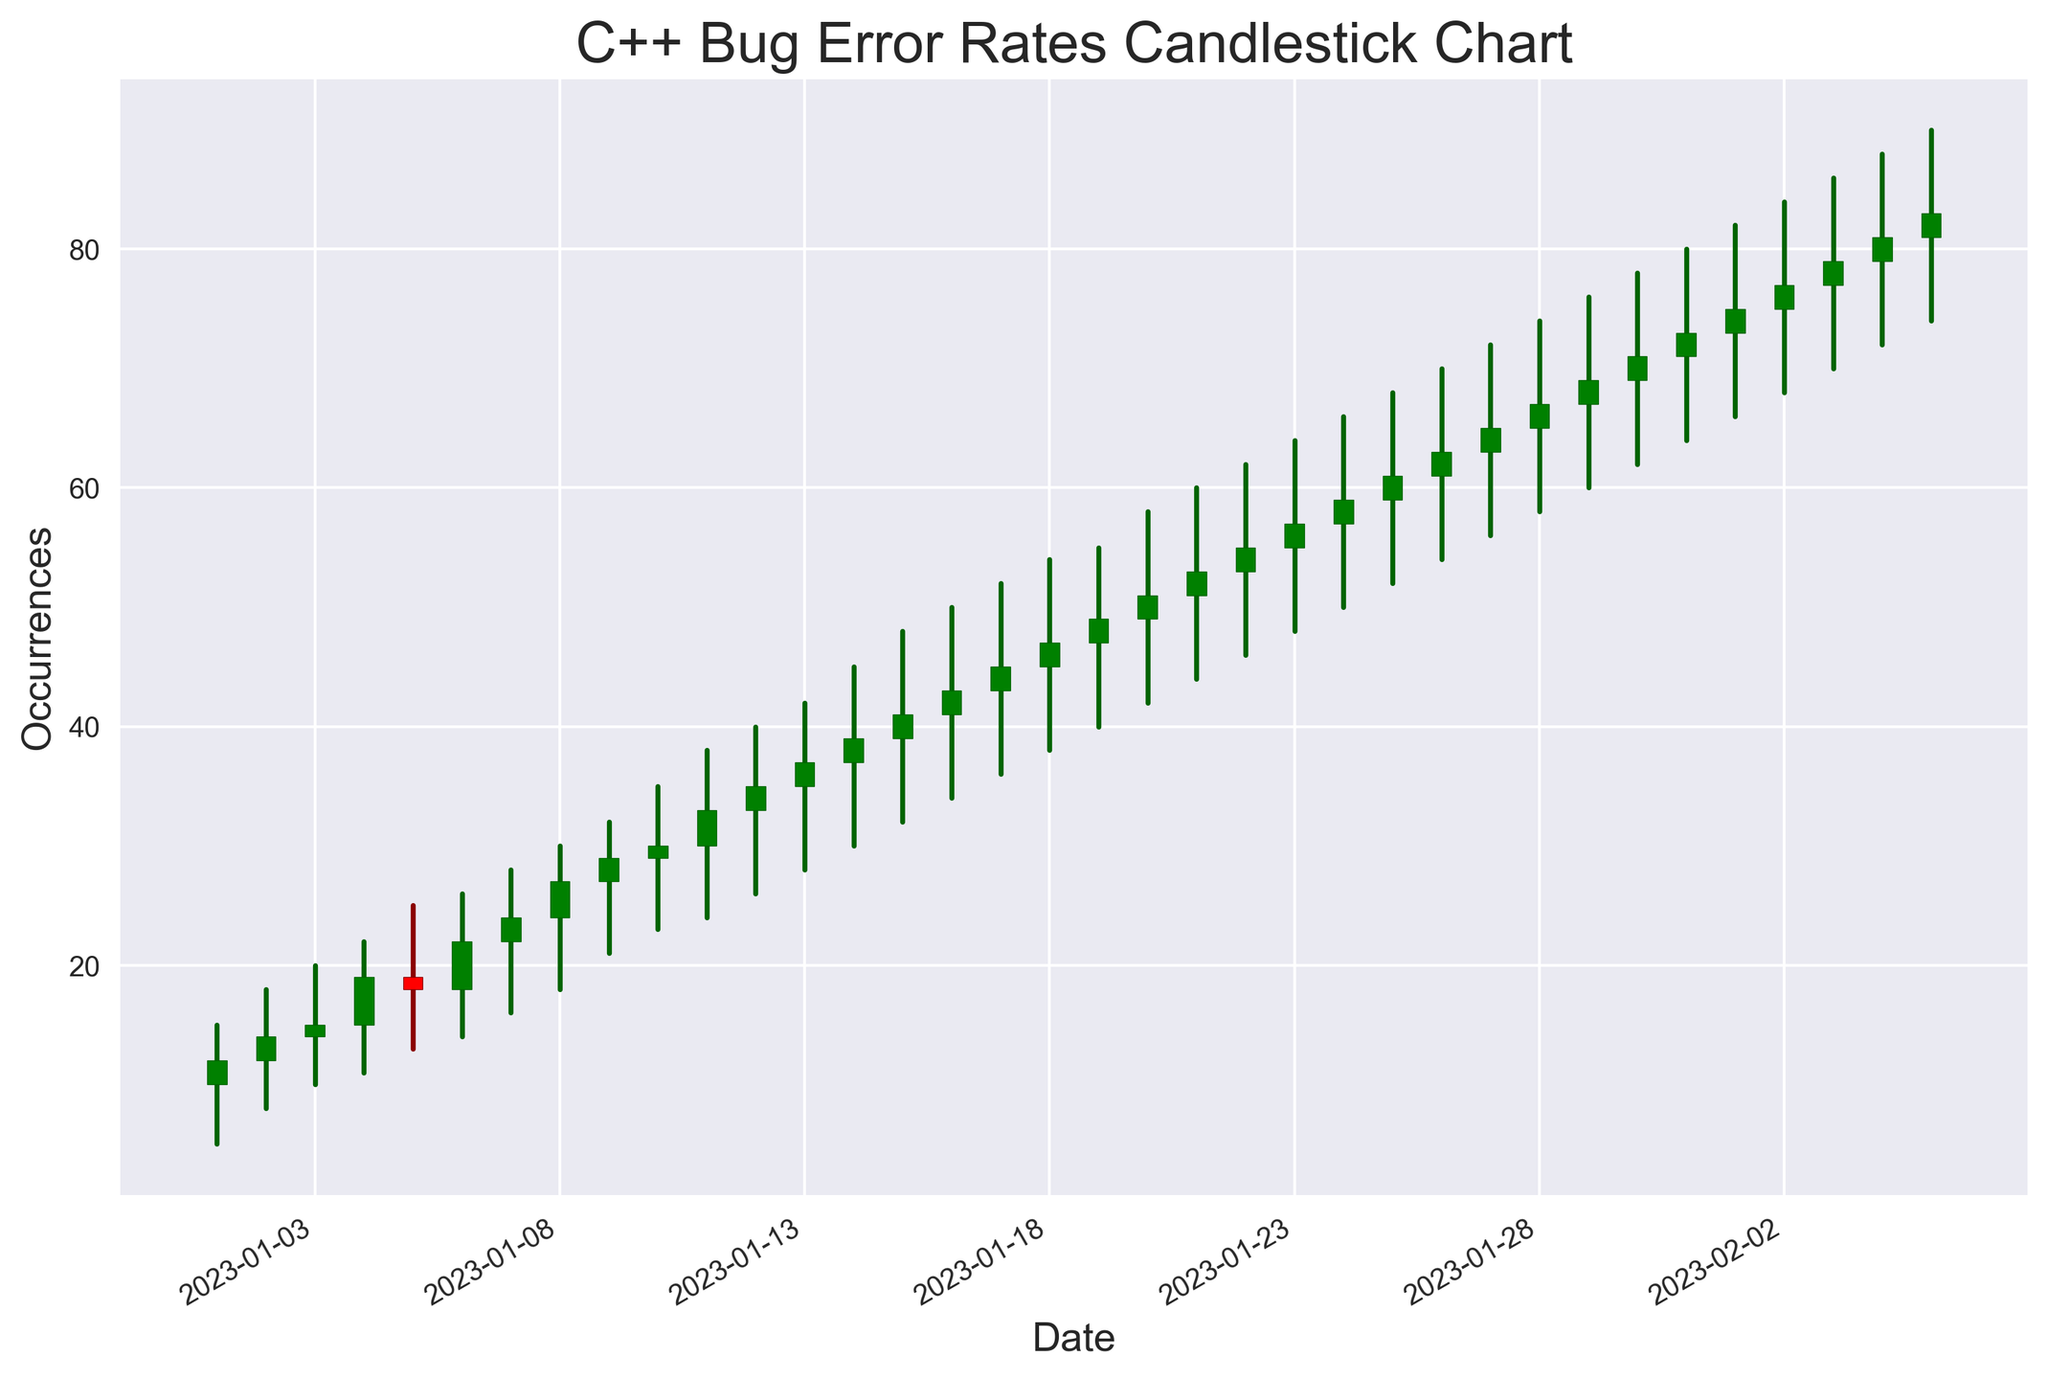What is the trend of Syntax Errors throughout the dates? Observe the green and red rectangles associated with Syntax Errors. Note their progression over the timeline from the beginning to the end, focusing on their occurrence and comparing their heights and positions.
Answer: Increasing Which type of bug shows the most consistent uptrend in occurrences over time? Analyze the trend of each type of bug by looking at the sequence of green and red rectangles over the timeline. Focus on how the closing values (top of green rectangles or bottom of red rectangles) change for each type.
Answer: Memory Leak On which date did the highest price occur for Runtime Error? Identify the green and red rectangles associated with Runtime Error and find the date where the highest value (high attribute) is observed.
Answer: 2023-01-15 Compare the average occurrence value of Syntax Errors and Logic Errors. Which one is higher? Calculate the average occurrence (closing prices) for Syntax Errors and Logic Errors over the given dates. Compare the two averages to determine which is higher.
Answer: Logic Errors are higher Which date had the largest difference between the high and low values for Memory Leak? For each date with Memory Leak, compute the difference between the high and low values. Identify the date with the largest difference.
Answer: 2023-01-04 How many times did the closing value fall below the opening value for Logic Errors? Count the number of red rectangles associated with Logic Errors, indicating that the closing value was lower than the opening value.
Answer: 0 times On which date was the bug type with the highest closing value observed? Identify the highest closing value across all dates and note the corresponding date and bug type.
Answer: 2023-02-05, Memory Leak Which bug type had the highest average opening value throughout the observed period? Calculate the average opening value for each bug type over the dates and compare to find the highest one.
Answer: Memory Leak 